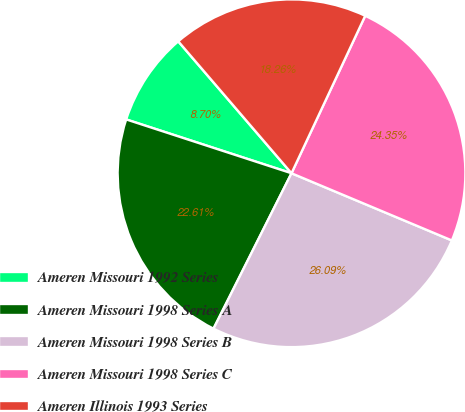Convert chart to OTSL. <chart><loc_0><loc_0><loc_500><loc_500><pie_chart><fcel>Ameren Missouri 1992 Series<fcel>Ameren Missouri 1998 Series A<fcel>Ameren Missouri 1998 Series B<fcel>Ameren Missouri 1998 Series C<fcel>Ameren Illinois 1993 Series<nl><fcel>8.7%<fcel>22.61%<fcel>26.09%<fcel>24.35%<fcel>18.26%<nl></chart> 